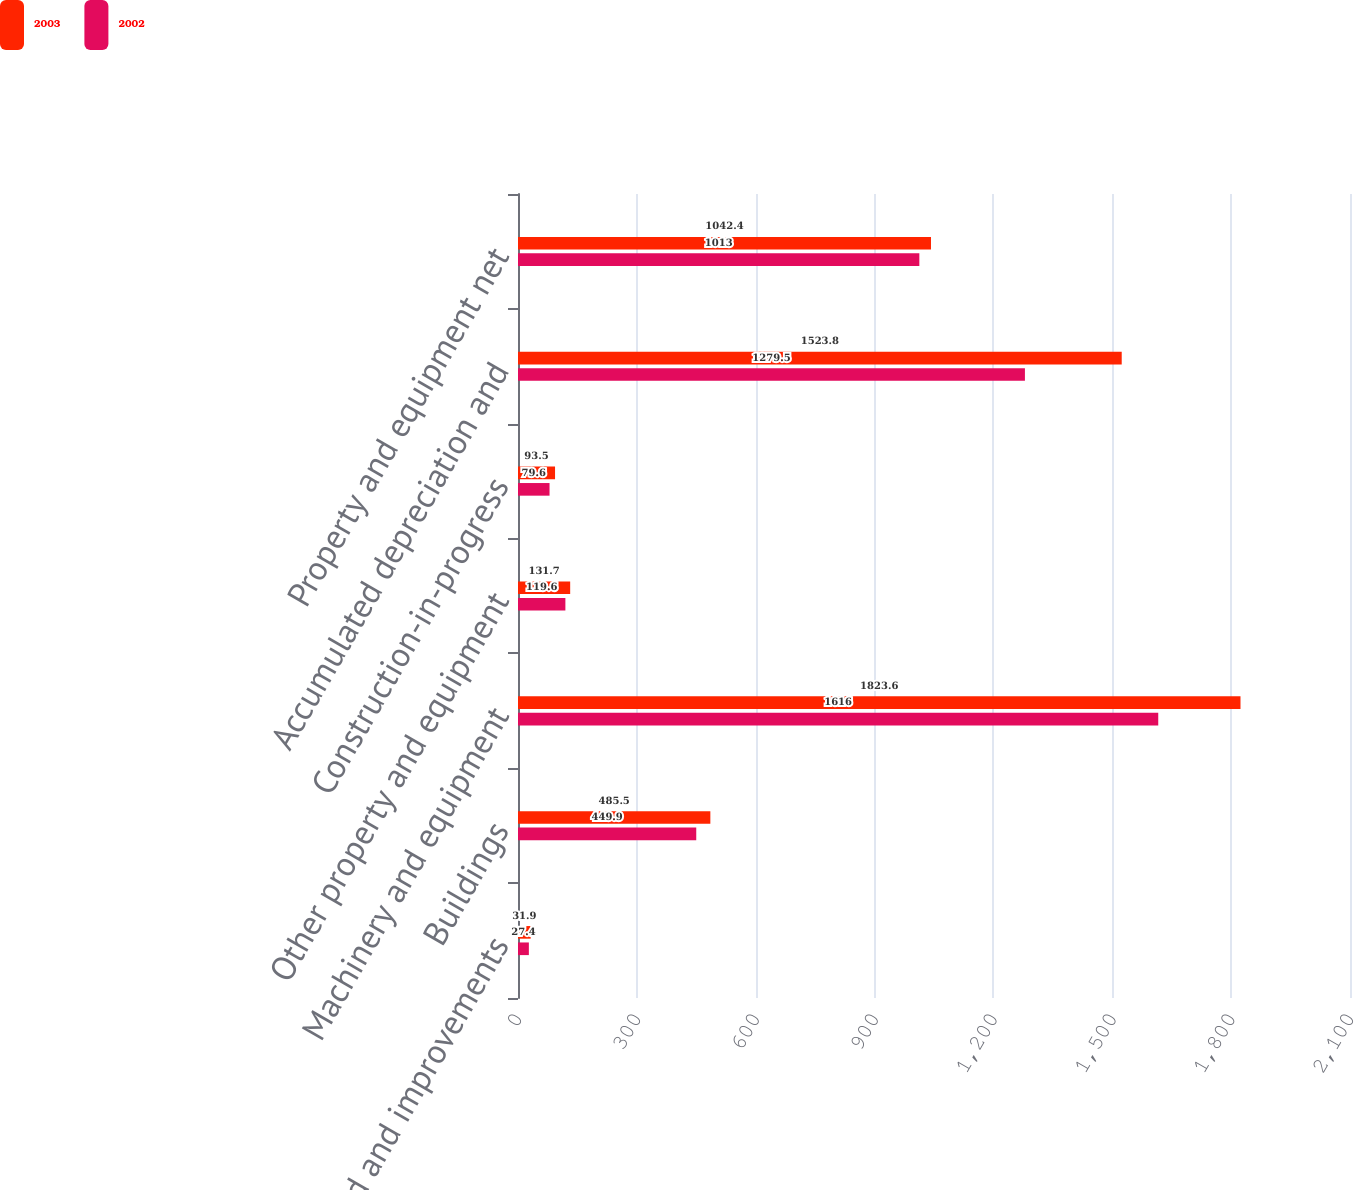Convert chart to OTSL. <chart><loc_0><loc_0><loc_500><loc_500><stacked_bar_chart><ecel><fcel>Land and improvements<fcel>Buildings<fcel>Machinery and equipment<fcel>Other property and equipment<fcel>Construction-in-progress<fcel>Accumulated depreciation and<fcel>Property and equipment net<nl><fcel>2003<fcel>31.9<fcel>485.5<fcel>1823.6<fcel>131.7<fcel>93.5<fcel>1523.8<fcel>1042.4<nl><fcel>2002<fcel>27.4<fcel>449.9<fcel>1616<fcel>119.6<fcel>79.6<fcel>1279.5<fcel>1013<nl></chart> 